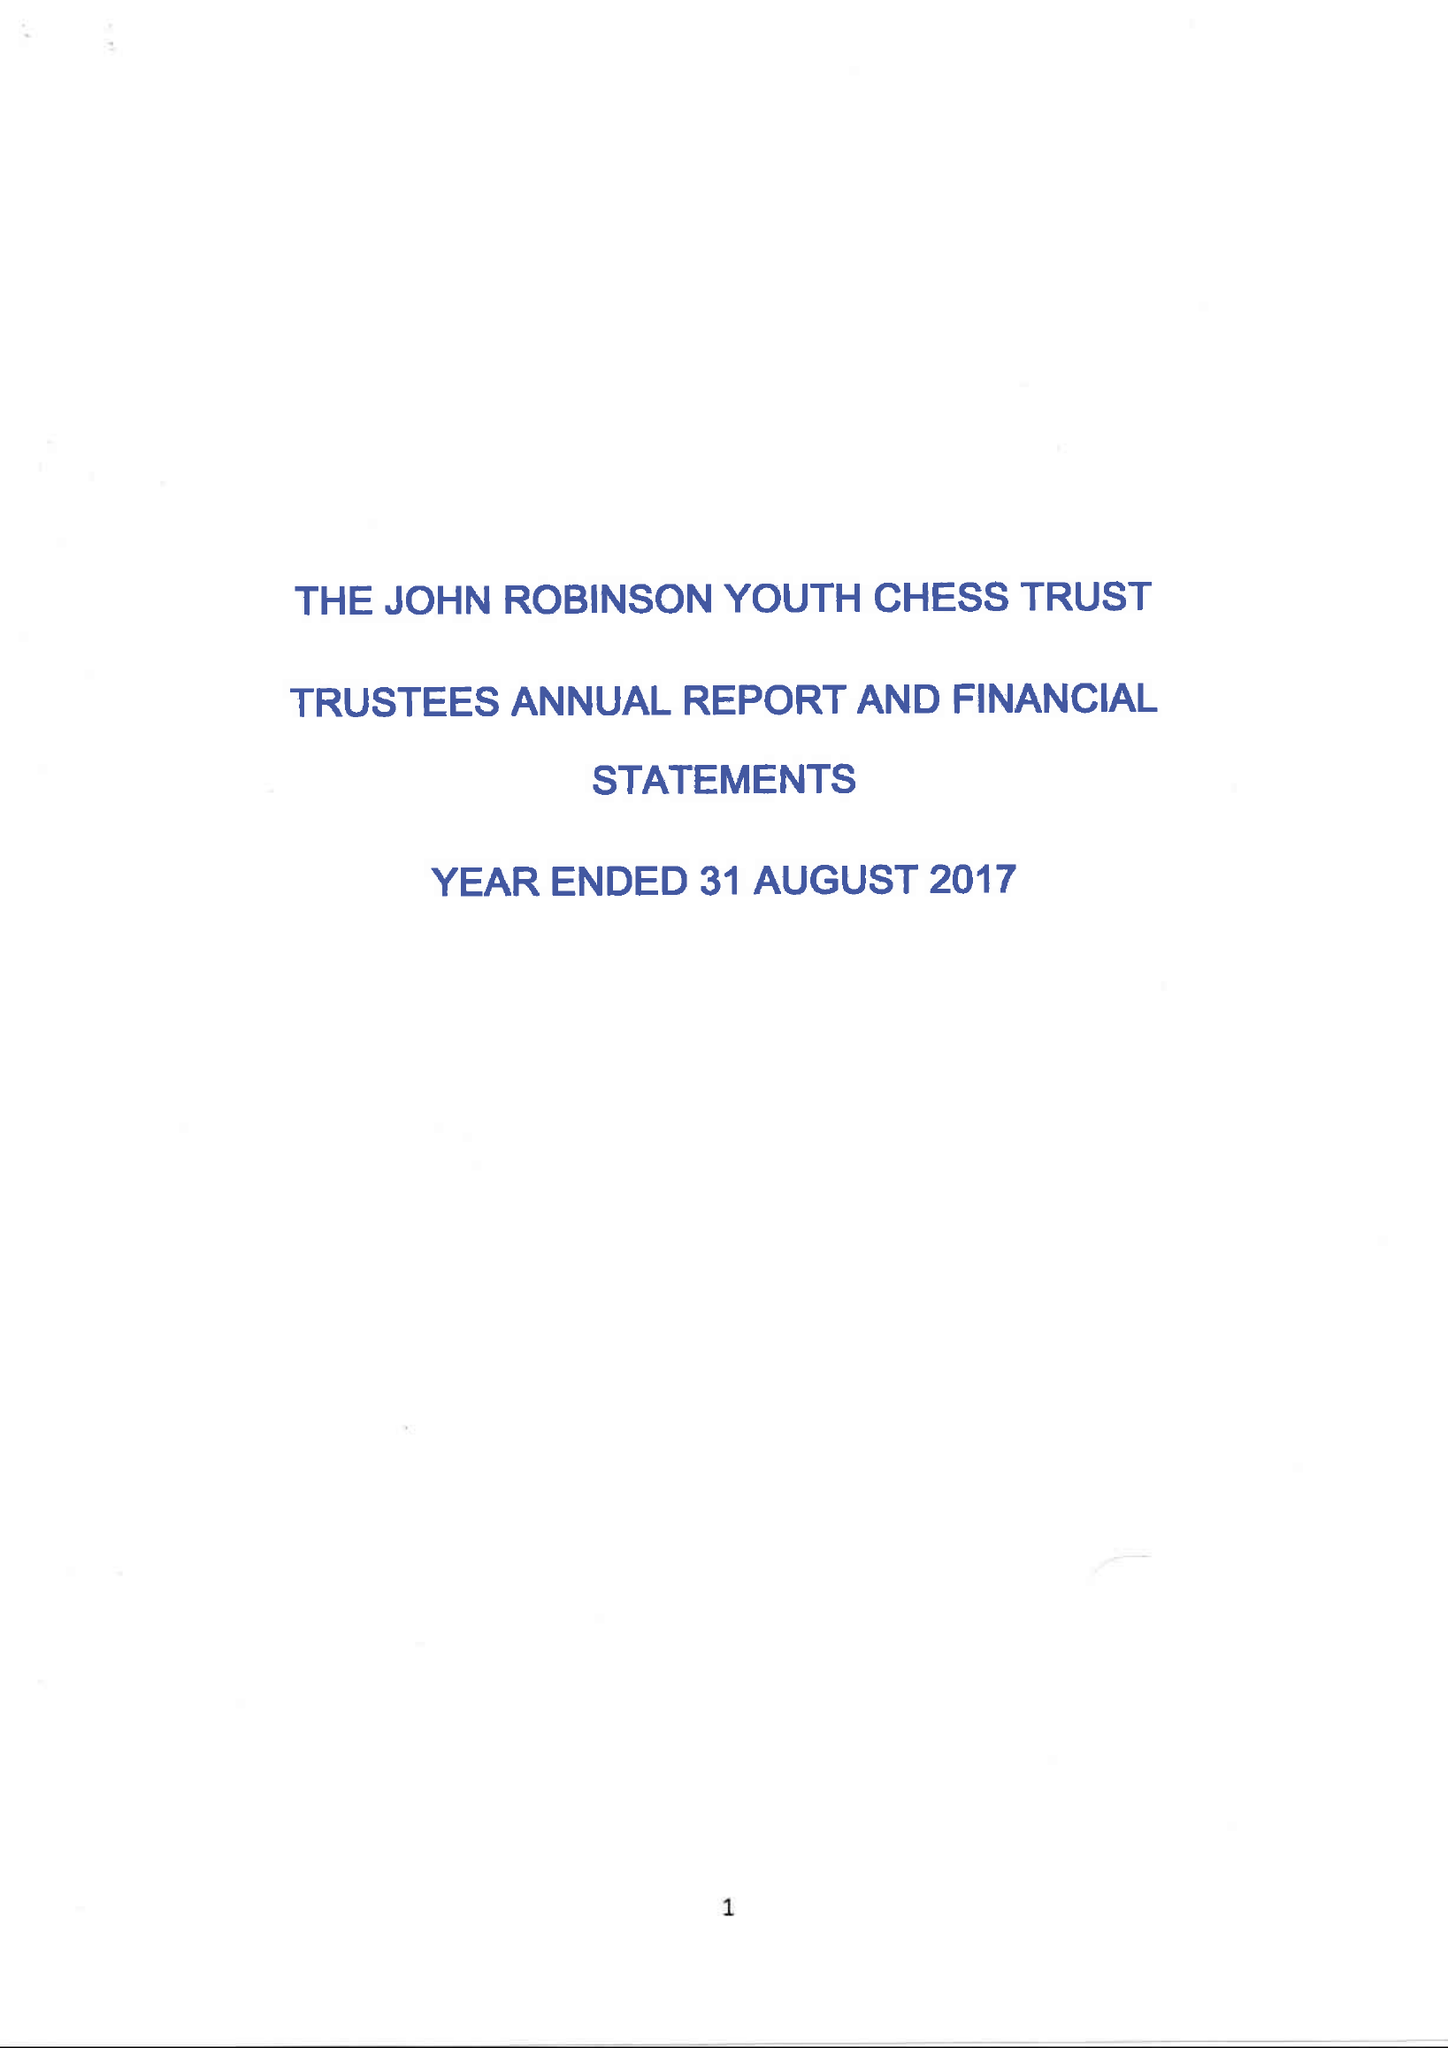What is the value for the address__street_line?
Answer the question using a single word or phrase. 6 MAYFIELD 